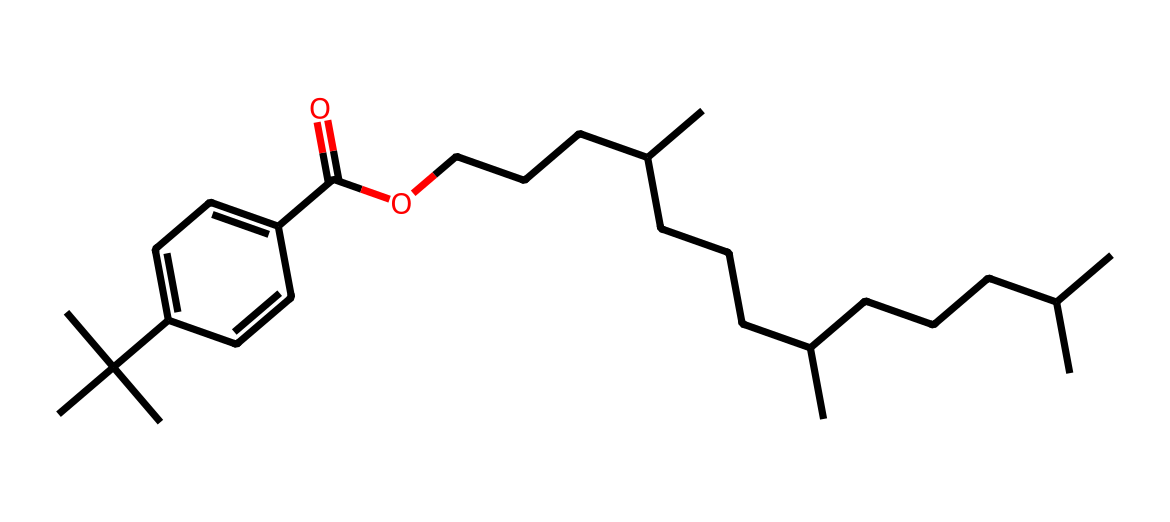What type of functional group is present in this chemical? The chemical structure contains a carboxylic acid functional group, indicated by the -COOH component (C(=O)O), which includes a carbonyl (C=O) and a hydroxyl (-OH) group.
Answer: carboxylic acid How many carbon atoms are present in this chemical? To determine the number of carbon atoms, we count all the "C" in the SMILES representation. The representation shows 30 carbon atoms in total.
Answer: 30 What is the molecular weight of this chemical? The molecular weight can be calculated by adding the weights of all atoms represented in the chemical. The total comes to approximately 490 grams per mole.
Answer: 490 What does the branched structure suggest about its physical properties? The branched structure often leads to lower boiling points and increased solubility in non-polar solvents, indicating the chemical may have liquid properties typical of high-end fragrances.
Answer: lower boiling point How many double bonds are in the chemical structure? The only double bond present is in the carboxylic acid group (the C=O), indicating that the chemical contains one double bond.
Answer: 1 Is this chemical likely to be polar or non-polar? Considering the long carbon chains and the presence of the carboxylic acid group, the overall structure suggests it leans towards being non-polar due to the predominance of carbon chains.
Answer: non-polar 